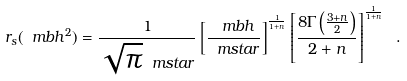Convert formula to latex. <formula><loc_0><loc_0><loc_500><loc_500>r _ { s } ( \ m b h ^ { 2 } ) = \frac { 1 } { \sqrt { \pi } \ m s t a r } \left [ \frac { \ m b h } { \ m s t a r } \right ] ^ { \frac { 1 } { 1 + n } } \left [ \frac { 8 \Gamma \left ( \frac { 3 + n } { 2 } \right ) } { 2 + n } \right ] ^ { \frac { 1 } { 1 + n } } \ .</formula> 